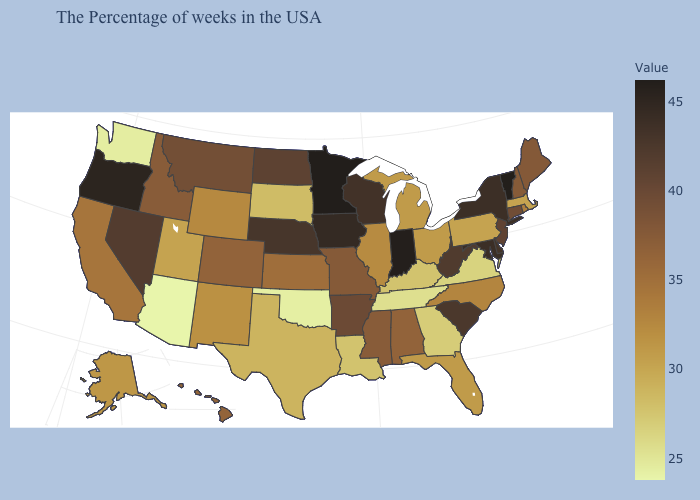Does Minnesota have the highest value in the MidWest?
Write a very short answer. Yes. Does Maryland have the highest value in the USA?
Quick response, please. No. Does Massachusetts have a higher value than North Carolina?
Concise answer only. No. Does Massachusetts have the lowest value in the Northeast?
Write a very short answer. Yes. Among the states that border Oregon , does Nevada have the lowest value?
Concise answer only. No. 